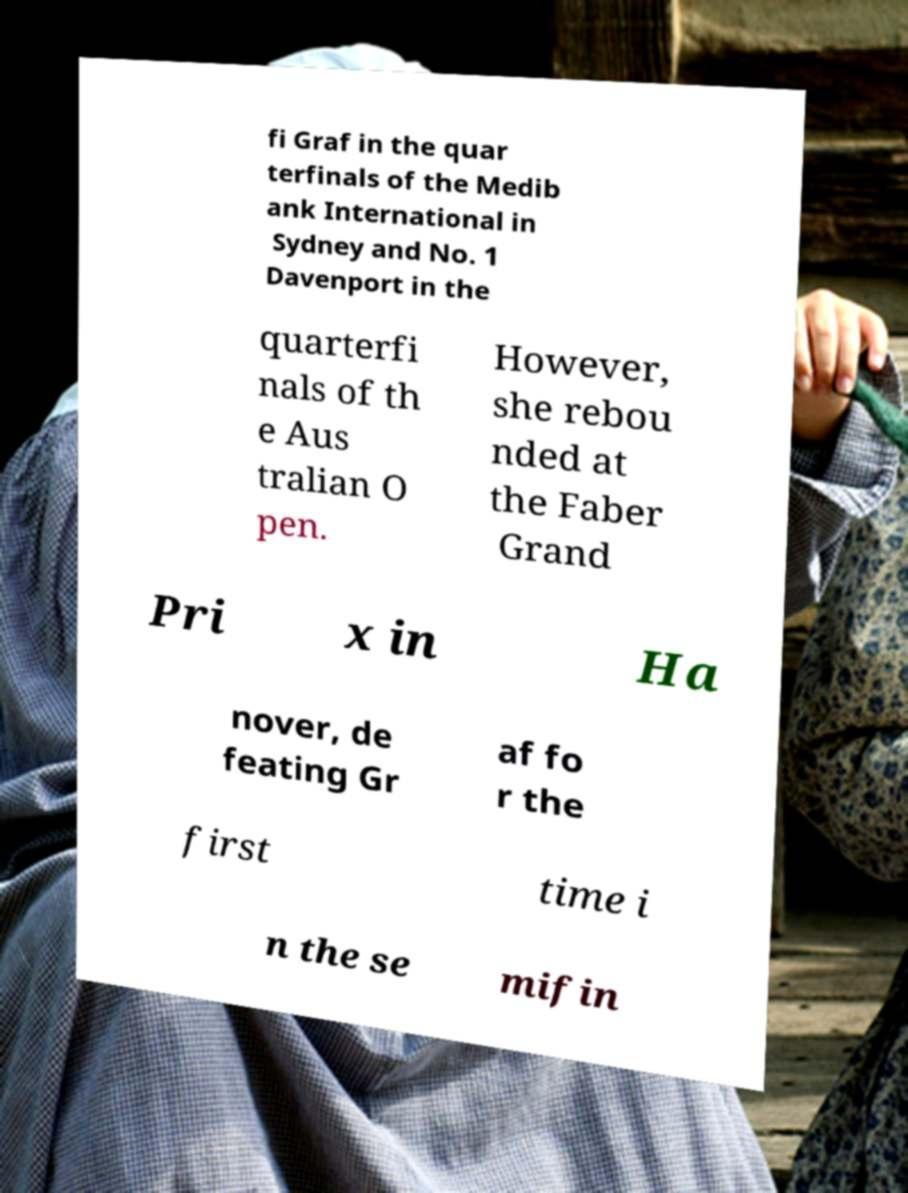What messages or text are displayed in this image? I need them in a readable, typed format. fi Graf in the quar terfinals of the Medib ank International in Sydney and No. 1 Davenport in the quarterfi nals of th e Aus tralian O pen. However, she rebou nded at the Faber Grand Pri x in Ha nover, de feating Gr af fo r the first time i n the se mifin 